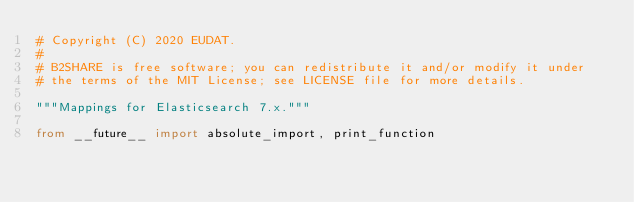<code> <loc_0><loc_0><loc_500><loc_500><_Python_># Copyright (C) 2020 EUDAT.
#
# B2SHARE is free software; you can redistribute it and/or modify it under
# the terms of the MIT License; see LICENSE file for more details.

"""Mappings for Elasticsearch 7.x."""

from __future__ import absolute_import, print_function
</code> 